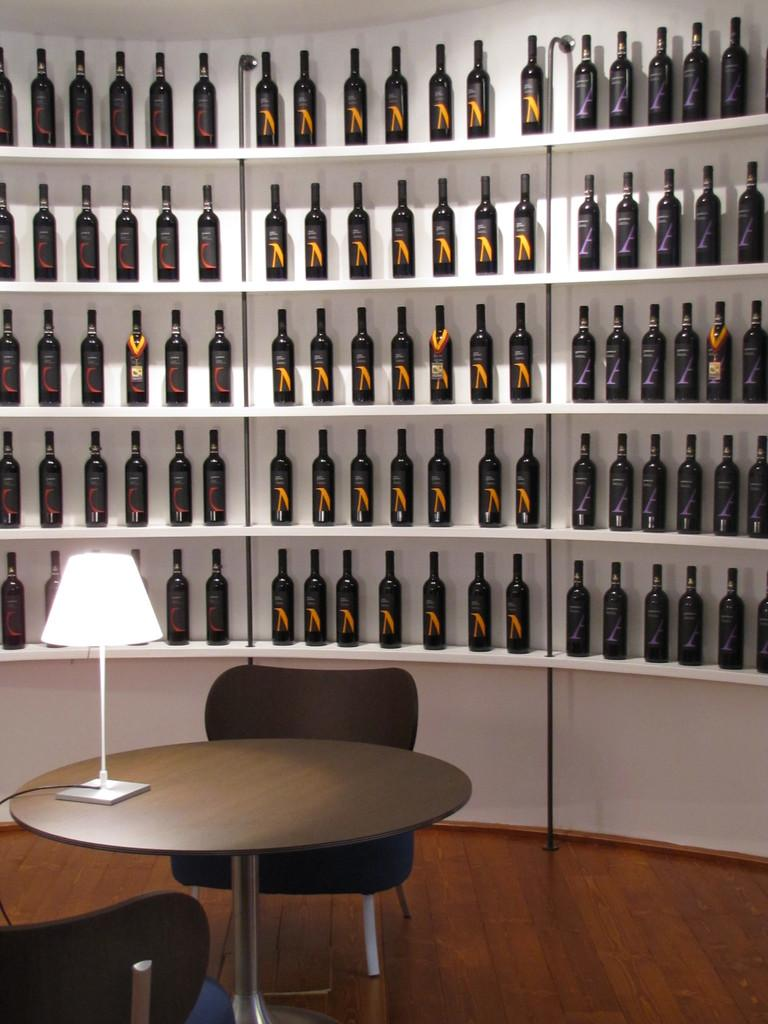What type of furniture is present in the image? There is a shelf, a table, and a chair in the image. What is kept on the shelf? Bottles are kept on the shelf. What type of lighting is present in the image? There is a table lamp in the image. How many children are jumping into the sea in the image? There are no children or sea present in the image; it features a shelf, table, chair, and table lamp. 